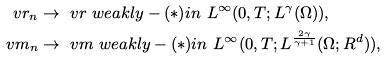<formula> <loc_0><loc_0><loc_500><loc_500>\ v r _ { n } & \to \ v r \ w e a k l y - ( * ) i n \ L ^ { \infty } ( 0 , T ; L ^ { \gamma } ( \Omega ) ) , \\ \ v m _ { n } & \to \ v m \ w e a k l y - ( * ) i n \ L ^ { \infty } ( 0 , T ; L ^ { \frac { 2 \gamma } { \gamma + 1 } } ( \Omega ; R ^ { d } ) ) ,</formula> 